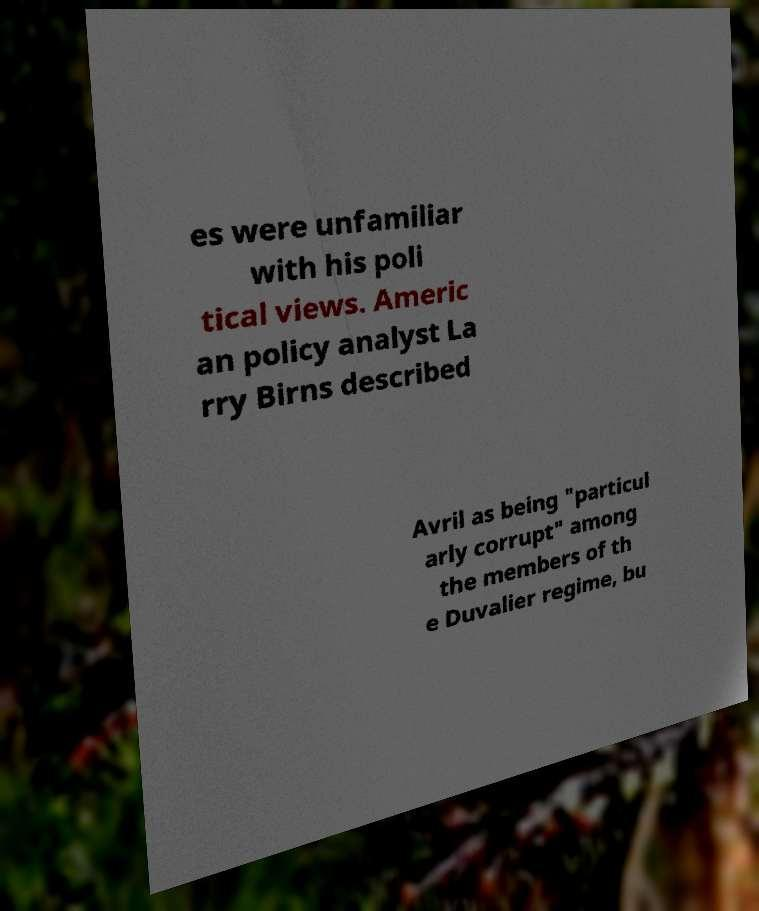I need the written content from this picture converted into text. Can you do that? es were unfamiliar with his poli tical views. Americ an policy analyst La rry Birns described Avril as being "particul arly corrupt" among the members of th e Duvalier regime, bu 